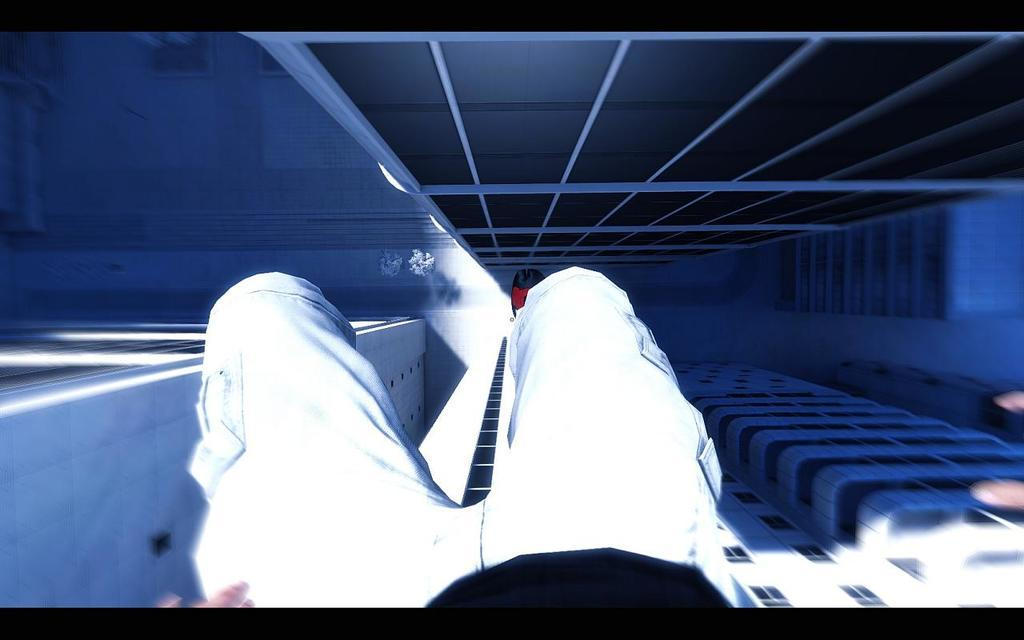What is the main focus of the image? The main focus of the image is persons' legs at the center. What can be seen at the bottom of the image? There are buildings at the bottom of the image. What type of amusement can be seen in the image? There is no amusement present in the image; it only features persons' legs and buildings. Can you tell me how many pets are visible in the image? There are no pets visible in the image. 